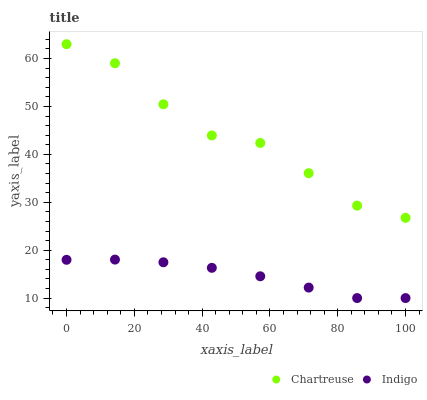Does Indigo have the minimum area under the curve?
Answer yes or no. Yes. Does Chartreuse have the maximum area under the curve?
Answer yes or no. Yes. Does Indigo have the maximum area under the curve?
Answer yes or no. No. Is Indigo the smoothest?
Answer yes or no. Yes. Is Chartreuse the roughest?
Answer yes or no. Yes. Is Indigo the roughest?
Answer yes or no. No. Does Indigo have the lowest value?
Answer yes or no. Yes. Does Chartreuse have the highest value?
Answer yes or no. Yes. Does Indigo have the highest value?
Answer yes or no. No. Is Indigo less than Chartreuse?
Answer yes or no. Yes. Is Chartreuse greater than Indigo?
Answer yes or no. Yes. Does Indigo intersect Chartreuse?
Answer yes or no. No. 